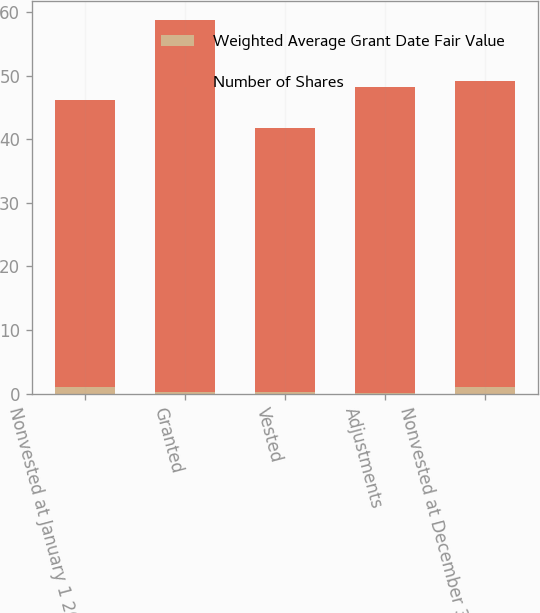Convert chart to OTSL. <chart><loc_0><loc_0><loc_500><loc_500><stacked_bar_chart><ecel><fcel>Nonvested at January 1 2006<fcel>Granted<fcel>Vested<fcel>Adjustments<fcel>Nonvested at December 31 2006<nl><fcel>Weighted Average Grant Date Fair Value<fcel>1<fcel>0.2<fcel>0.2<fcel>0.1<fcel>1.1<nl><fcel>Number of Shares<fcel>45.16<fcel>58.6<fcel>41.58<fcel>48.1<fcel>48.01<nl></chart> 